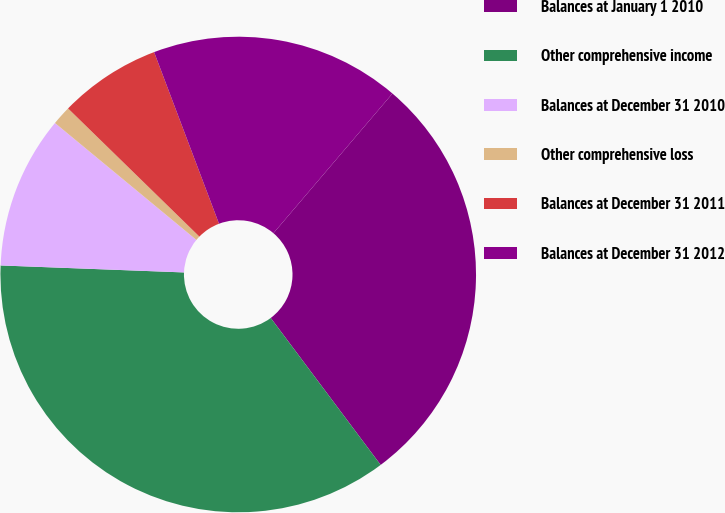Convert chart. <chart><loc_0><loc_0><loc_500><loc_500><pie_chart><fcel>Balances at January 1 2010<fcel>Other comprehensive income<fcel>Balances at December 31 2010<fcel>Other comprehensive loss<fcel>Balances at December 31 2011<fcel>Balances at December 31 2012<nl><fcel>28.55%<fcel>35.83%<fcel>10.39%<fcel>1.31%<fcel>6.94%<fcel>16.99%<nl></chart> 